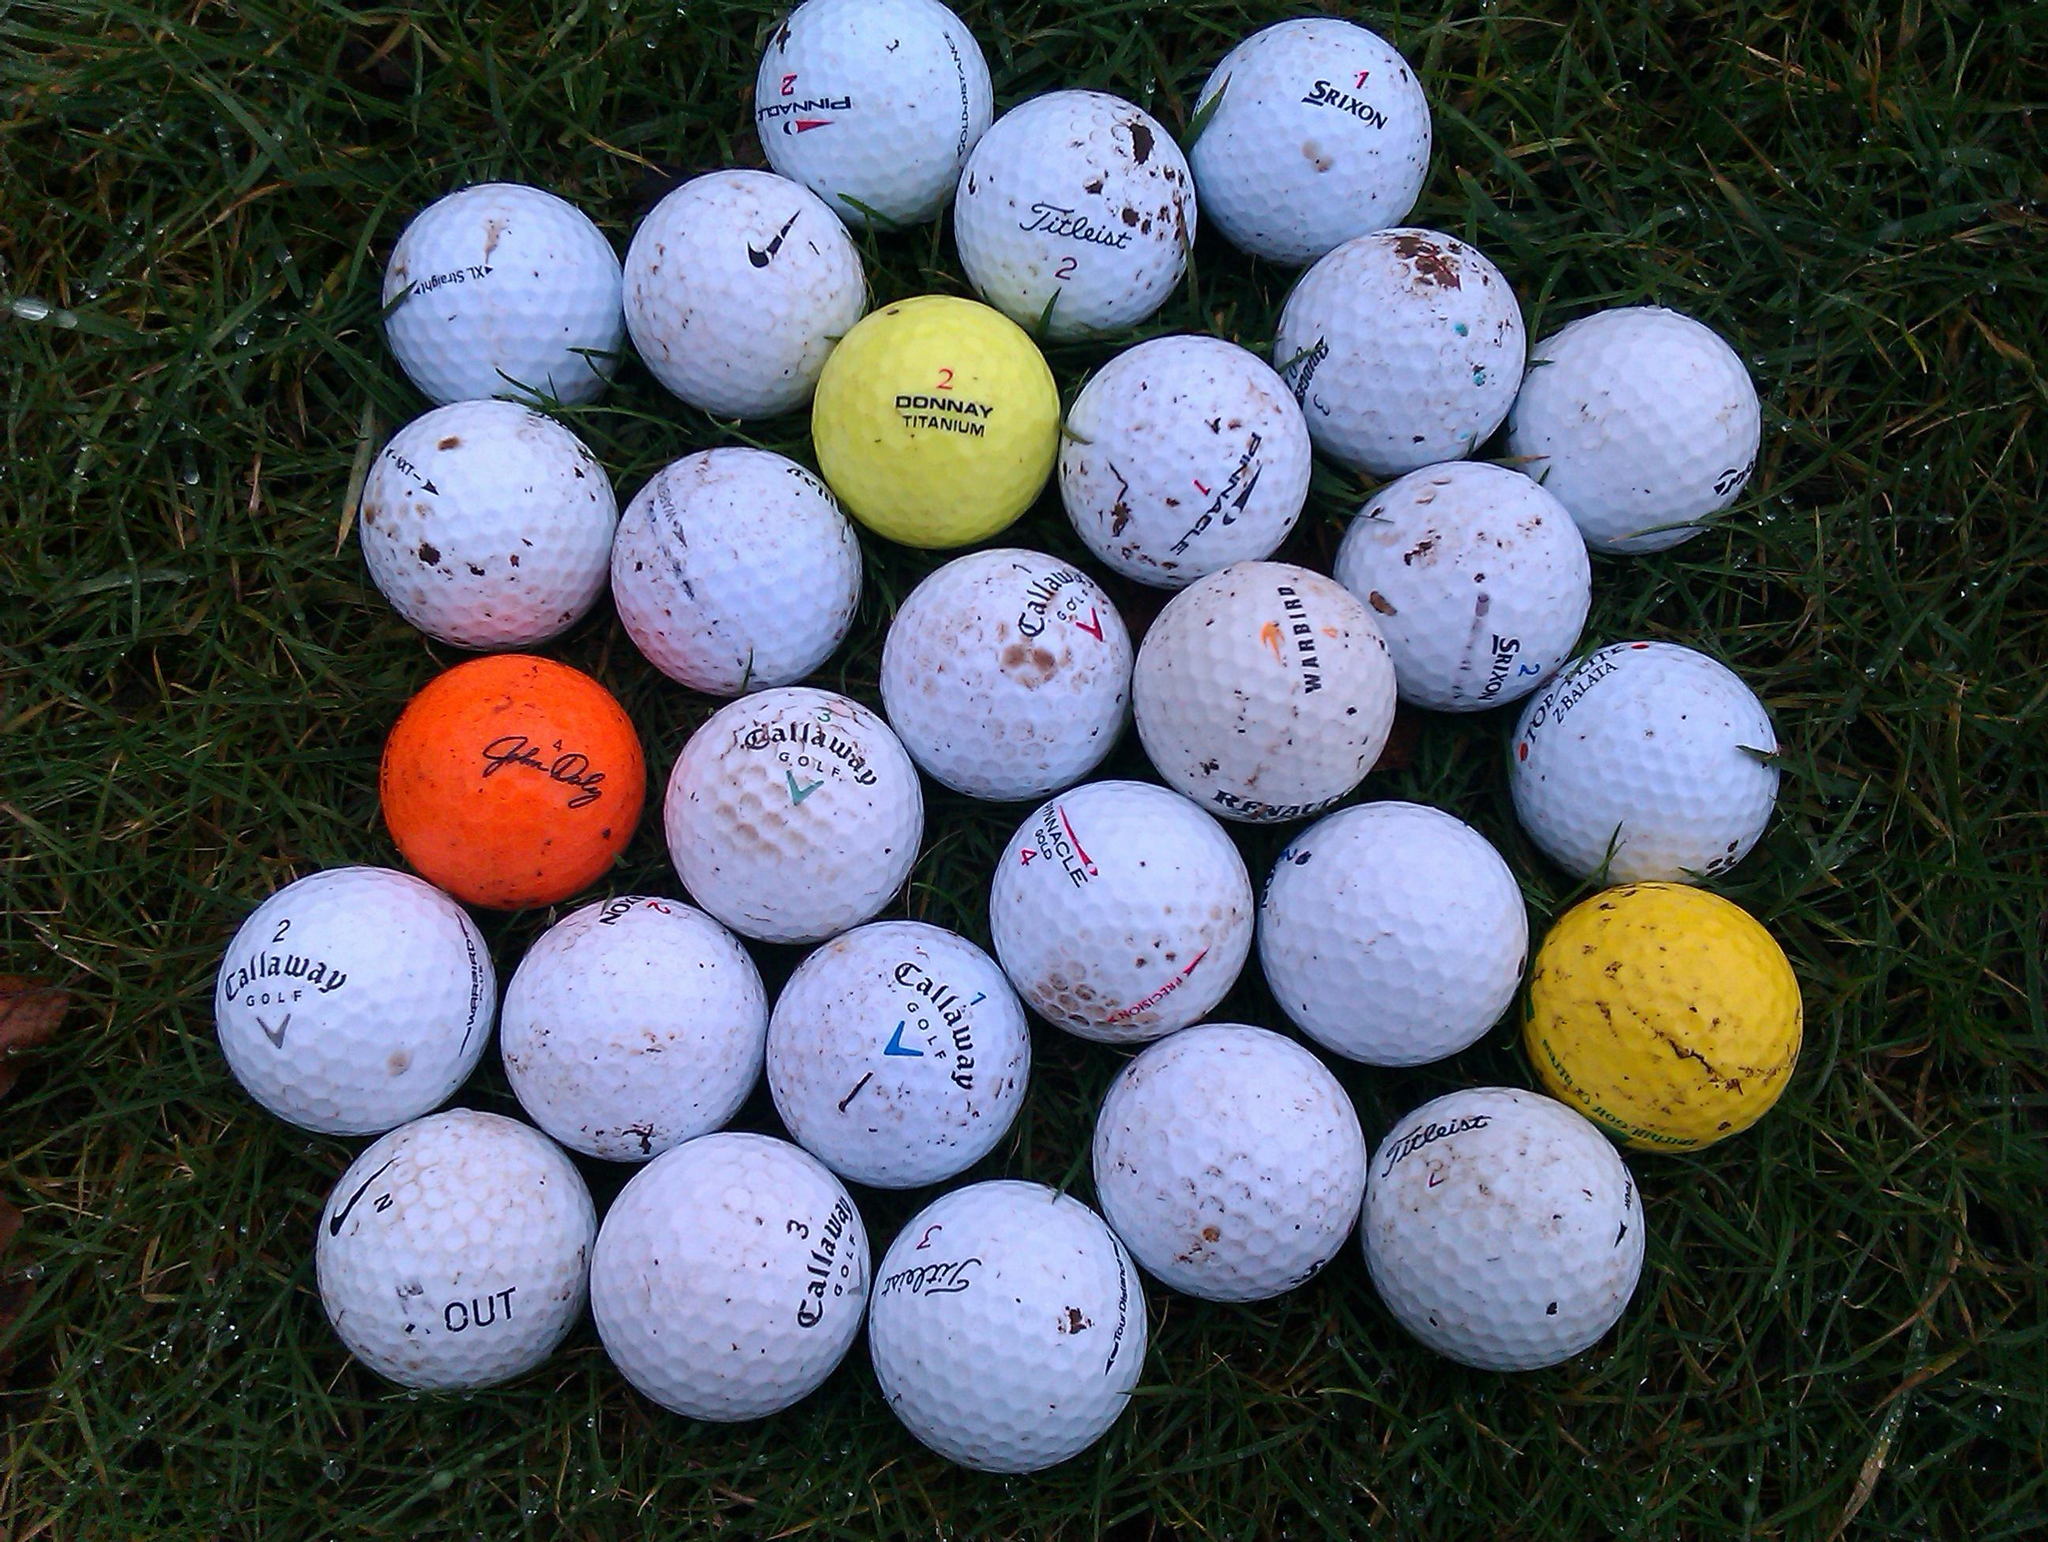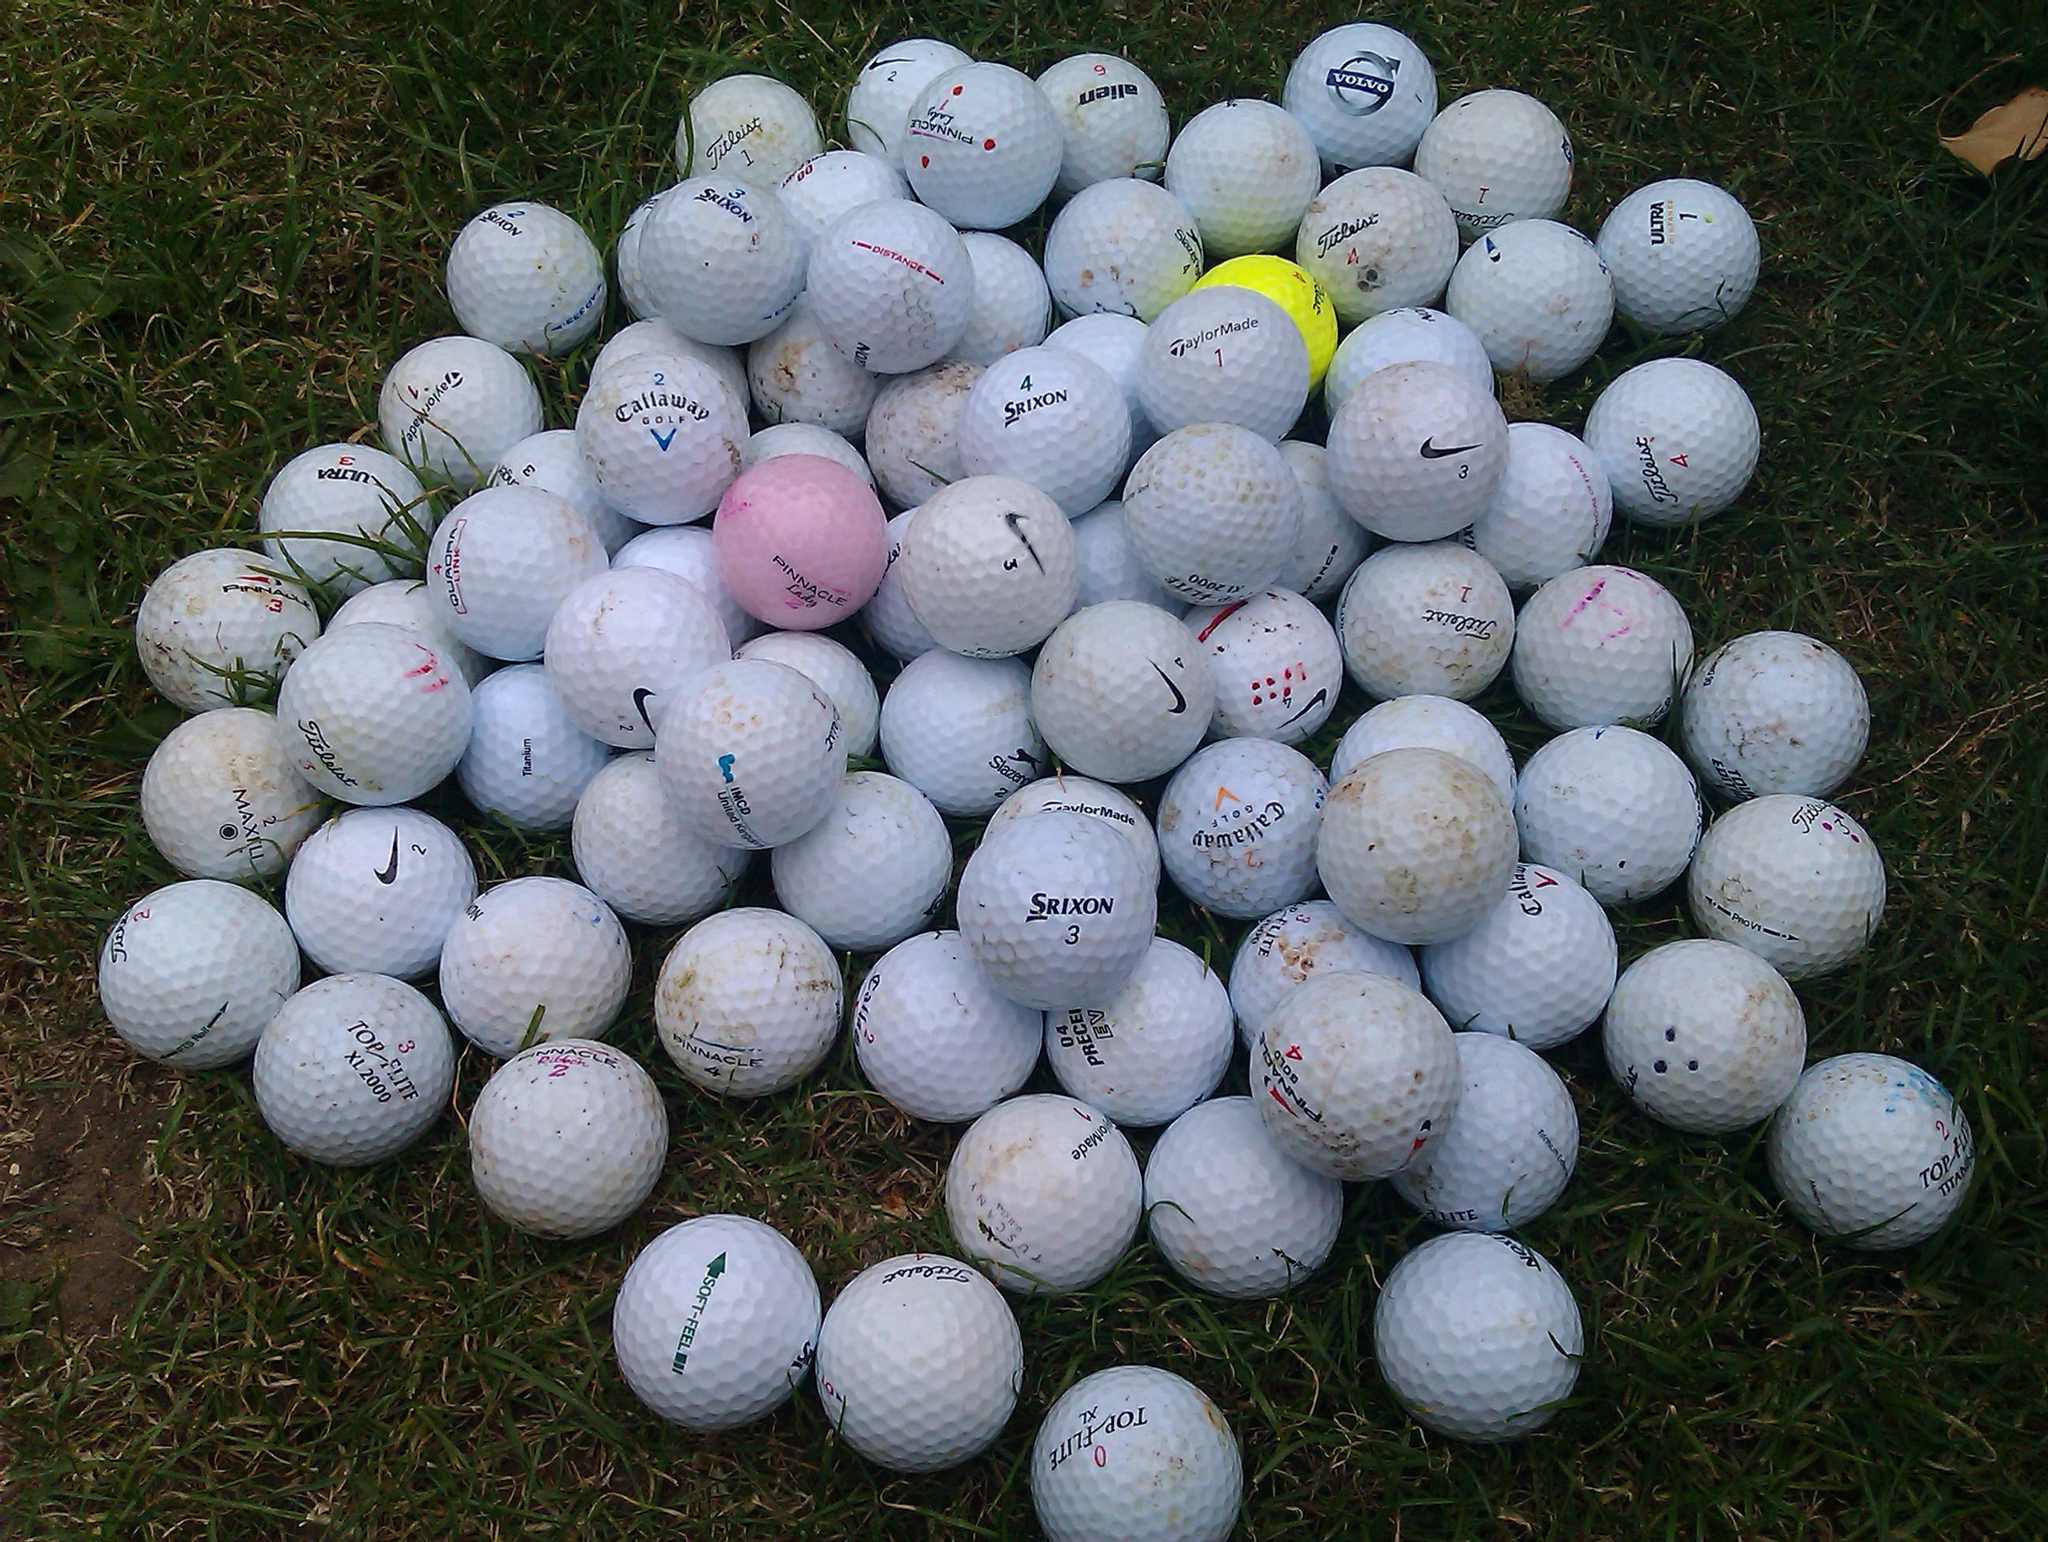The first image is the image on the left, the second image is the image on the right. For the images displayed, is the sentence "Each image contains only one actual, round golf ball." factually correct? Answer yes or no. No. The first image is the image on the left, the second image is the image on the right. Evaluate the accuracy of this statement regarding the images: "There are two balls sitting directly on the grass.". Is it true? Answer yes or no. No. 